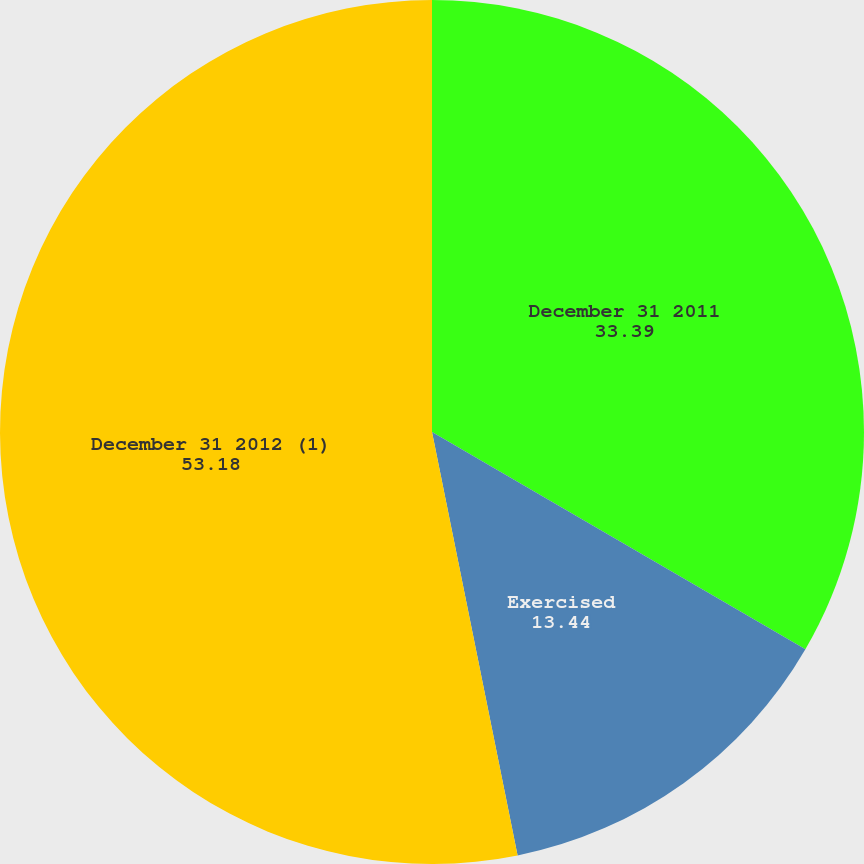Convert chart to OTSL. <chart><loc_0><loc_0><loc_500><loc_500><pie_chart><fcel>December 31 2011<fcel>Exercised<fcel>December 31 2012 (1)<nl><fcel>33.39%<fcel>13.44%<fcel>53.18%<nl></chart> 